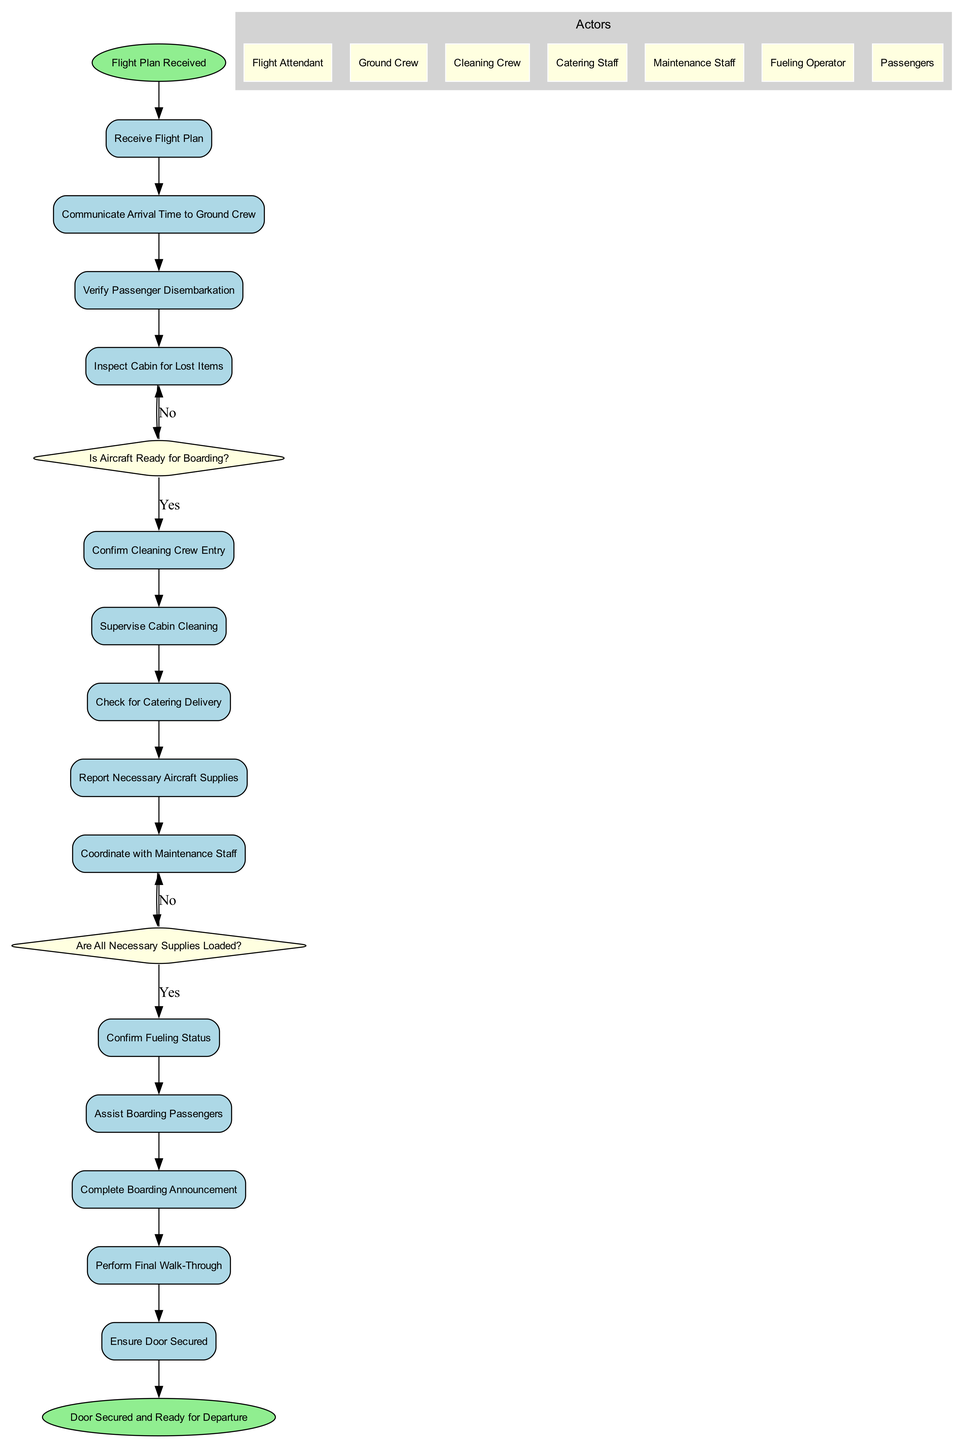What is the starting point of the diagram? The starting point is indicated in the diagram as the first node connected to the rest of the actions, which is "Flight Plan Received."
Answer: Flight Plan Received How many action nodes are present in the diagram? The action nodes are items listed under "actions." Counting them gives a total of 14 action nodes in the diagram.
Answer: 14 What decision point follows the action "Inspect Cabin for Lost Items"? The decision point that follows this action is labeled as "Is Aircraft Ready for Boarding?" which determines the next steps based on passenger disembarkation verification.
Answer: Is Aircraft Ready for Boarding? Which action is connected to the decision "Are All Necessary Supplies Loaded?" The action connected to this decision is "Coordinate with Maintenance Staff," which precedes the second decision point that checks if necessary supplies are loaded.
Answer: Coordinate with Maintenance Staff What is the last action performed before the endpoint? The last action performed is "Ensure Door Secured," which occurs before reaching the endpoint indicating readiness for departure.
Answer: Ensure Door Secured What are the roles of the actors outlined in the diagram? Actors are listed in the diagram under a cluster labeled "Actors," and the roles include Flight Attendant, Ground Crew, Cleaning Crew, Catering Staff, Maintenance Staff, Fueling Operator, and Passengers.
Answer: Flight Attendant, Ground Crew, Cleaning Crew, Catering Staff, Maintenance Staff, Fueling Operator, Passengers How is the flow of actions structured in the diagram? The flow is structured as a sequence of connected action nodes, with two decision points determining the path based on specific conditions, creating conditional branching depending on the state of the aircraft and supplied materials.
Answer: Sequential with decision points What confirms the aircraft is ready for departure in this diagram? The diagram indicates that the aircraft is ready for departure upon reaching the last action "Ensure Door Secured" and transitioning to the endpoint node.
Answer: Door Secured and Ready for Departure 